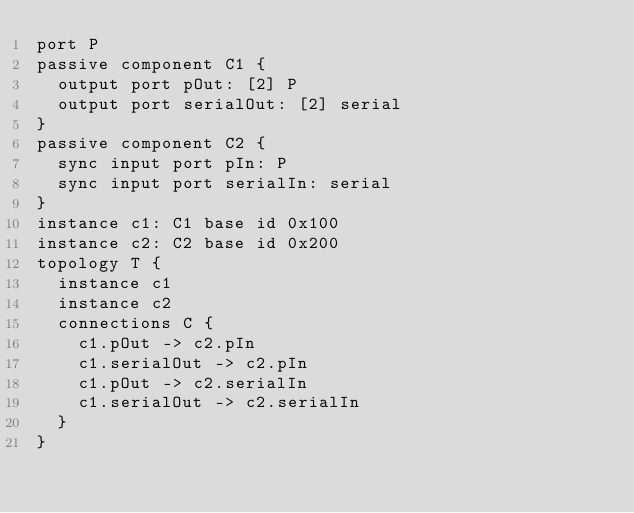Convert code to text. <code><loc_0><loc_0><loc_500><loc_500><_FORTRAN_>port P
passive component C1 {
  output port pOut: [2] P
  output port serialOut: [2] serial
}
passive component C2 {
  sync input port pIn: P
  sync input port serialIn: serial
}
instance c1: C1 base id 0x100
instance c2: C2 base id 0x200
topology T {
  instance c1
  instance c2
  connections C {
    c1.pOut -> c2.pIn
    c1.serialOut -> c2.pIn
    c1.pOut -> c2.serialIn
    c1.serialOut -> c2.serialIn
  }
}
</code> 